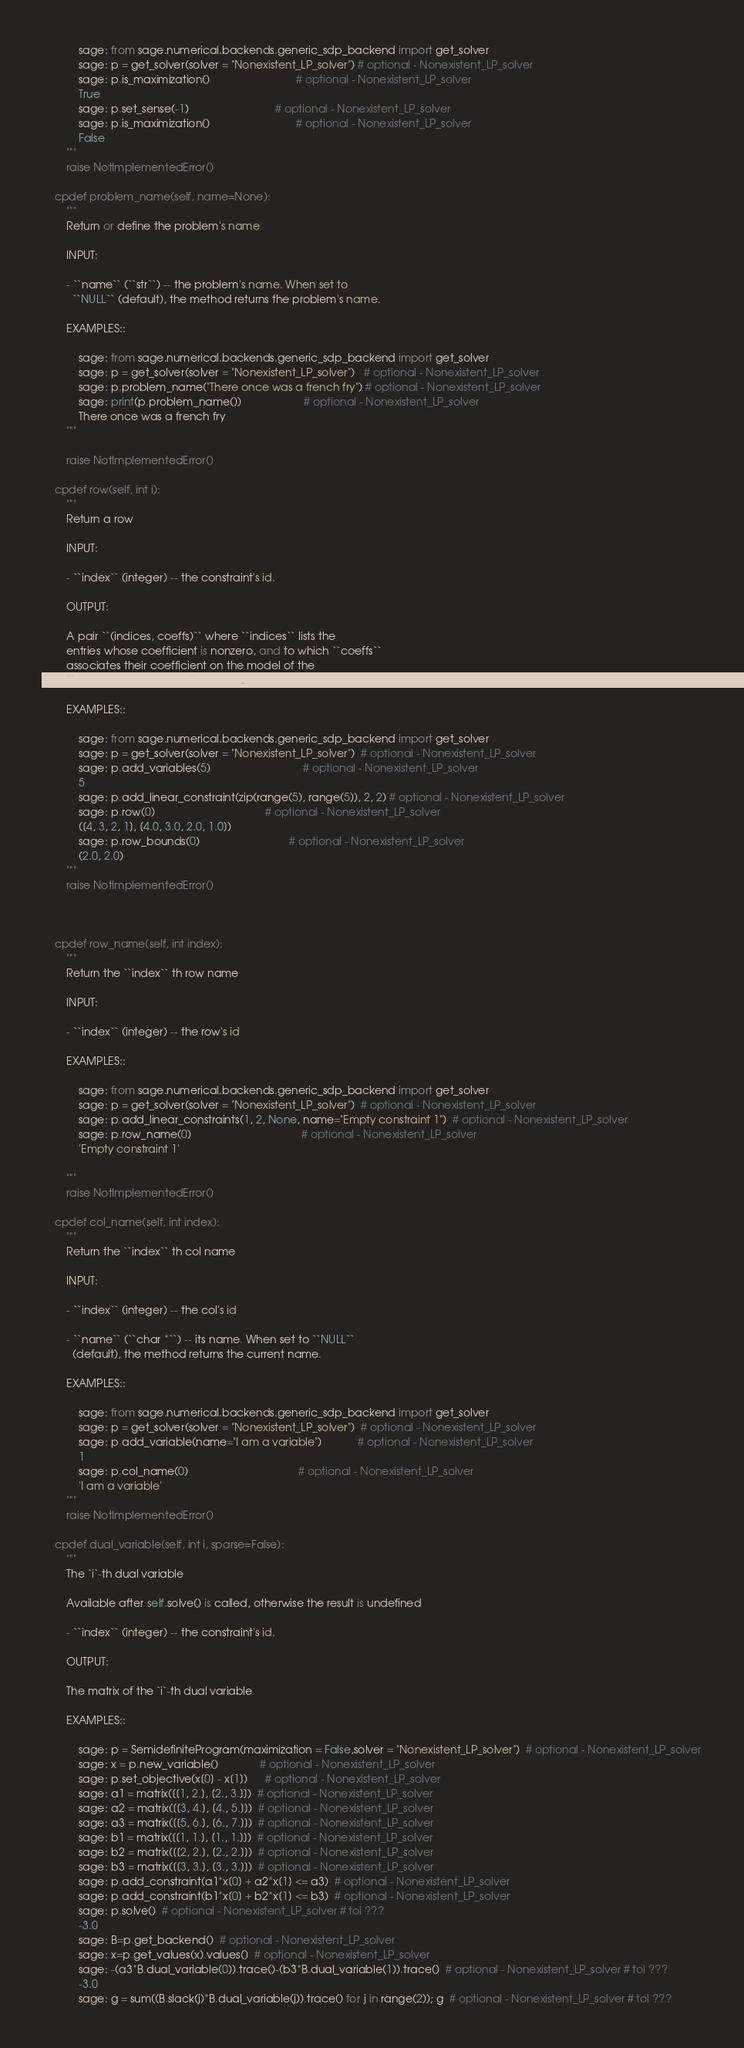Convert code to text. <code><loc_0><loc_0><loc_500><loc_500><_Cython_>
            sage: from sage.numerical.backends.generic_sdp_backend import get_solver
            sage: p = get_solver(solver = "Nonexistent_LP_solver") # optional - Nonexistent_LP_solver
            sage: p.is_maximization()                             # optional - Nonexistent_LP_solver
            True
            sage: p.set_sense(-1)                             # optional - Nonexistent_LP_solver
            sage: p.is_maximization()                             # optional - Nonexistent_LP_solver
            False
        """
        raise NotImplementedError()

    cpdef problem_name(self, name=None):
        """
        Return or define the problem's name

        INPUT:

        - ``name`` (``str``) -- the problem's name. When set to
          ``NULL`` (default), the method returns the problem's name.

        EXAMPLES::

            sage: from sage.numerical.backends.generic_sdp_backend import get_solver
            sage: p = get_solver(solver = "Nonexistent_LP_solver")   # optional - Nonexistent_LP_solver
            sage: p.problem_name("There once was a french fry") # optional - Nonexistent_LP_solver
            sage: print(p.problem_name())                     # optional - Nonexistent_LP_solver
            There once was a french fry
        """

        raise NotImplementedError()

    cpdef row(self, int i):
        """
        Return a row

        INPUT:

        - ``index`` (integer) -- the constraint's id.

        OUTPUT:

        A pair ``(indices, coeffs)`` where ``indices`` lists the
        entries whose coefficient is nonzero, and to which ``coeffs``
        associates their coefficient on the model of the
        ``add_linear_constraint`` method.

        EXAMPLES::

            sage: from sage.numerical.backends.generic_sdp_backend import get_solver
            sage: p = get_solver(solver = "Nonexistent_LP_solver")  # optional - Nonexistent_LP_solver
            sage: p.add_variables(5)                               # optional - Nonexistent_LP_solver
            5
            sage: p.add_linear_constraint(zip(range(5), range(5)), 2, 2) # optional - Nonexistent_LP_solver
            sage: p.row(0)                                     # optional - Nonexistent_LP_solver
            ([4, 3, 2, 1], [4.0, 3.0, 2.0, 1.0])
            sage: p.row_bounds(0)                              # optional - Nonexistent_LP_solver
            (2.0, 2.0)
        """
        raise NotImplementedError()



    cpdef row_name(self, int index):
        """
        Return the ``index`` th row name

        INPUT:

        - ``index`` (integer) -- the row's id

        EXAMPLES::

            sage: from sage.numerical.backends.generic_sdp_backend import get_solver
            sage: p = get_solver(solver = "Nonexistent_LP_solver")  # optional - Nonexistent_LP_solver
            sage: p.add_linear_constraints(1, 2, None, name="Empty constraint 1")  # optional - Nonexistent_LP_solver
            sage: p.row_name(0)                                     # optional - Nonexistent_LP_solver
            'Empty constraint 1'

        """
        raise NotImplementedError()

    cpdef col_name(self, int index):
        """
        Return the ``index`` th col name

        INPUT:

        - ``index`` (integer) -- the col's id

        - ``name`` (``char *``) -- its name. When set to ``NULL``
          (default), the method returns the current name.

        EXAMPLES::

            sage: from sage.numerical.backends.generic_sdp_backend import get_solver
            sage: p = get_solver(solver = "Nonexistent_LP_solver")  # optional - Nonexistent_LP_solver
            sage: p.add_variable(name="I am a variable")            # optional - Nonexistent_LP_solver
            1
            sage: p.col_name(0)                                     # optional - Nonexistent_LP_solver
            'I am a variable'
        """
        raise NotImplementedError()

    cpdef dual_variable(self, int i, sparse=False):
        """
        The `i`-th dual variable

        Available after self.solve() is called, otherwise the result is undefined

        - ``index`` (integer) -- the constraint's id.

        OUTPUT:

        The matrix of the `i`-th dual variable

        EXAMPLES::

            sage: p = SemidefiniteProgram(maximization = False,solver = "Nonexistent_LP_solver")  # optional - Nonexistent_LP_solver
            sage: x = p.new_variable()              # optional - Nonexistent_LP_solver
            sage: p.set_objective(x[0] - x[1])      # optional - Nonexistent_LP_solver
            sage: a1 = matrix([[1, 2.], [2., 3.]])  # optional - Nonexistent_LP_solver
            sage: a2 = matrix([[3, 4.], [4., 5.]])  # optional - Nonexistent_LP_solver
            sage: a3 = matrix([[5, 6.], [6., 7.]])  # optional - Nonexistent_LP_solver
            sage: b1 = matrix([[1, 1.], [1., 1.]])  # optional - Nonexistent_LP_solver
            sage: b2 = matrix([[2, 2.], [2., 2.]])  # optional - Nonexistent_LP_solver
            sage: b3 = matrix([[3, 3.], [3., 3.]])  # optional - Nonexistent_LP_solver
            sage: p.add_constraint(a1*x[0] + a2*x[1] <= a3)  # optional - Nonexistent_LP_solver
            sage: p.add_constraint(b1*x[0] + b2*x[1] <= b3)  # optional - Nonexistent_LP_solver
            sage: p.solve()  # optional - Nonexistent_LP_solver # tol ???
            -3.0
            sage: B=p.get_backend()  # optional - Nonexistent_LP_solver
            sage: x=p.get_values(x).values()  # optional - Nonexistent_LP_solver
            sage: -(a3*B.dual_variable(0)).trace()-(b3*B.dual_variable(1)).trace()  # optional - Nonexistent_LP_solver # tol ???
            -3.0
            sage: g = sum((B.slack(j)*B.dual_variable(j)).trace() for j in range(2)); g  # optional - Nonexistent_LP_solver # tol ???</code> 